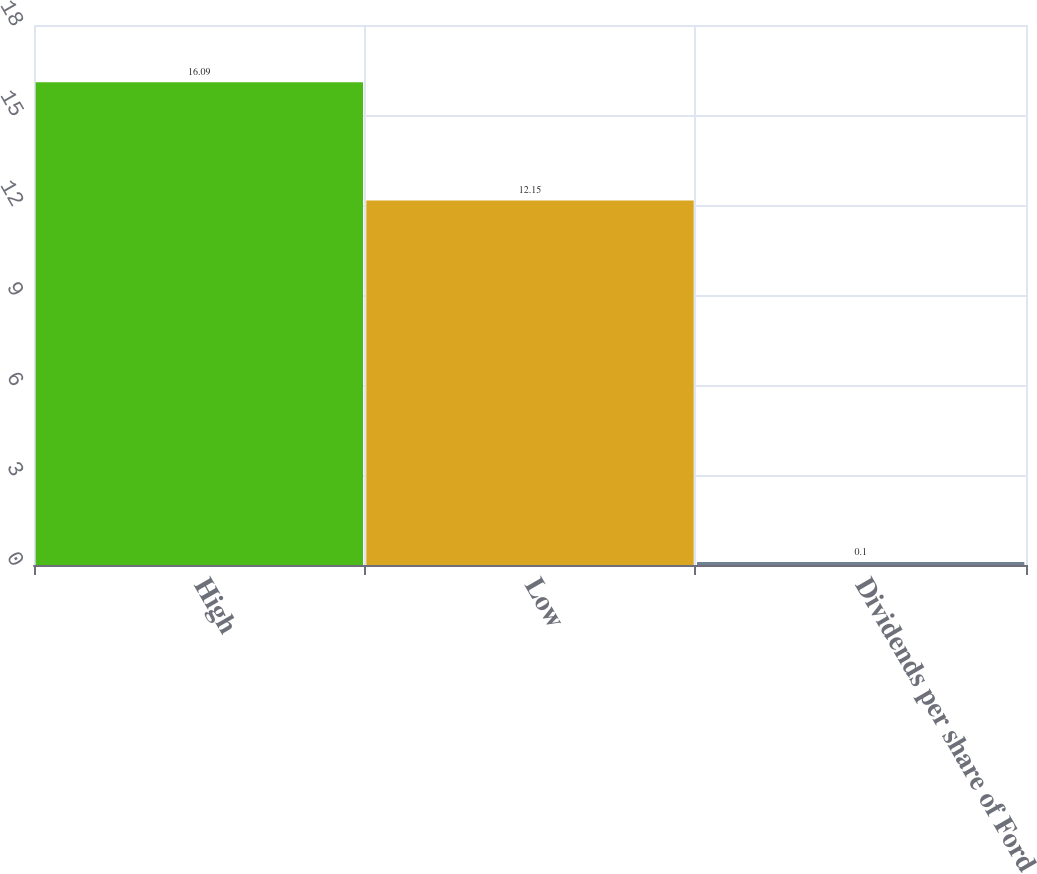Convert chart. <chart><loc_0><loc_0><loc_500><loc_500><bar_chart><fcel>High<fcel>Low<fcel>Dividends per share of Ford<nl><fcel>16.09<fcel>12.15<fcel>0.1<nl></chart> 